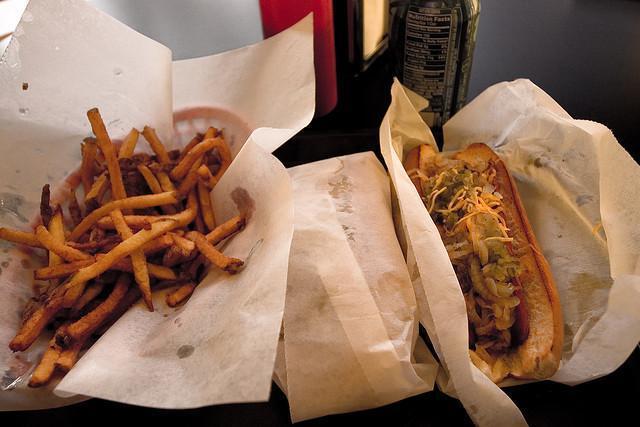How many people wears a while t-shirt in the image?
Give a very brief answer. 0. 